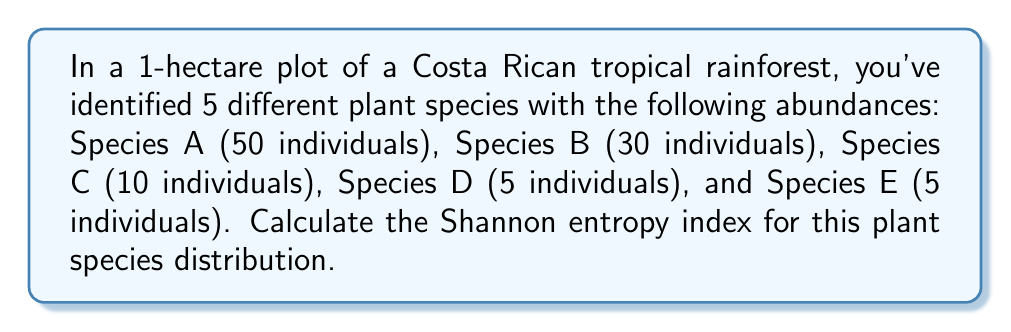Can you solve this math problem? To calculate the Shannon entropy index for this plant species distribution, we'll follow these steps:

1. Calculate the total number of individuals:
   $N = 50 + 30 + 10 + 5 + 5 = 100$

2. Calculate the proportion (p_i) of each species:
   Species A: $p_A = 50/100 = 0.5$
   Species B: $p_B = 30/100 = 0.3$
   Species C: $p_C = 10/100 = 0.1$
   Species D: $p_D = 5/100 = 0.05$
   Species E: $p_E = 5/100 = 0.05$

3. The Shannon entropy formula is:
   $$H = -\sum_{i=1}^{S} p_i \ln(p_i)$$
   where $S$ is the number of species, and $p_i$ is the proportion of individuals belonging to the $i$-th species.

4. Calculate $p_i \ln(p_i)$ for each species:
   Species A: $0.5 \ln(0.5) \approx -0.3466$
   Species B: $0.3 \ln(0.3) \approx -0.3611$
   Species C: $0.1 \ln(0.1) \approx -0.2303$
   Species D: $0.05 \ln(0.05) \approx -0.1498$
   Species E: $0.05 \ln(0.05) \approx -0.1498$

5. Sum the negative values:
   $$H = -(-0.3466 - 0.3611 - 0.2303 - 0.1498 - 0.1498)$$

6. Calculate the final result:
   $$H = 1.2376$$
Answer: $1.2376$ 